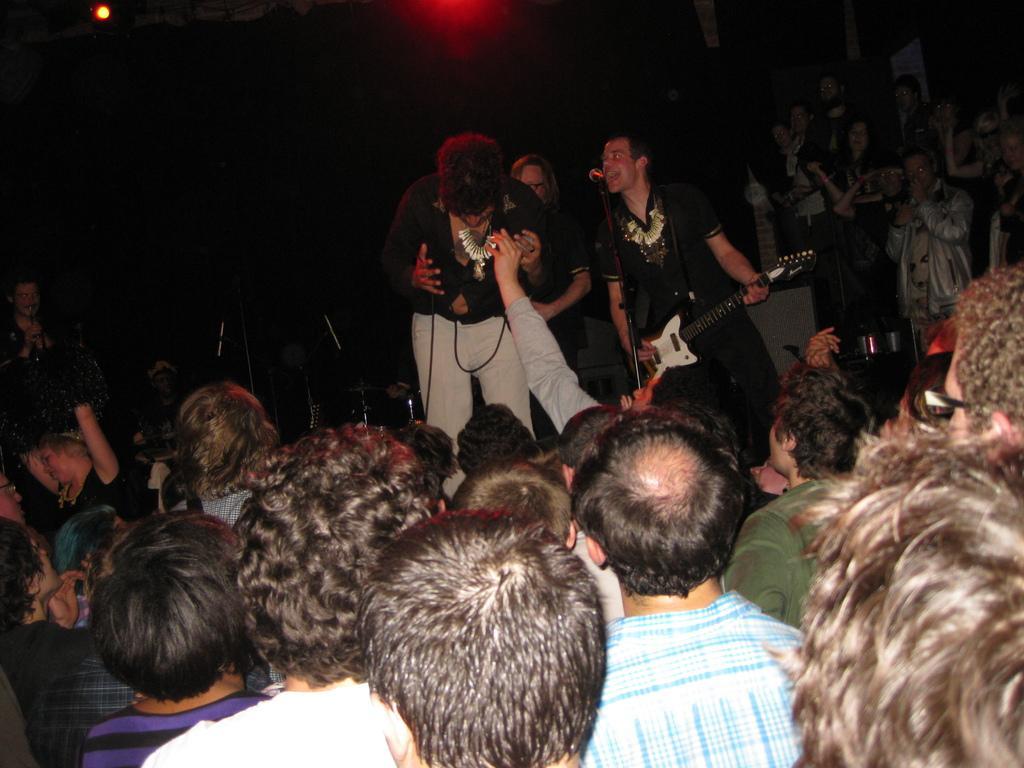In one or two sentences, can you explain what this image depicts? In this image I can see group of people. Background I can see a person standing singing in front of the microphone and holding a musical instrument. I can also see the other person standing wearing black shirt and white color pant, and I can see dark background. 